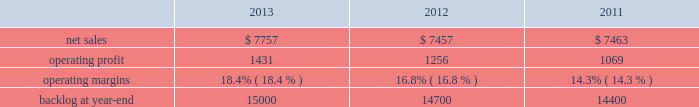Warfighter information network-tactical ( win-t ) ; command , control , battle management and communications ( c2bmc ) ; and twic ) .
Partially offsetting the decreases were higher net sales of approximately $ 140 million from qtc , which was acquired early in the fourth quarter of 2011 ; and about $ 65 million from increased activity on numerous other programs , primarily federal cyber security programs and ptds operational support .
Is&gs 2019 operating profit for 2012 decreased $ 66 million , or 8% ( 8 % ) , compared to 2011 .
The decrease was attributable to lower operating profit of approximately $ 50 million due to the favorable impact of the odin contract completion in 2011 ; about $ 25 million due to an increase in reserves for performance issues related to an international airborne surveillance system in 2012 ; and approximately $ 20 million due to lower volume on certain programs ( primarily c2bmc and win-t ) .
Partially offsetting the decreases was an increase in operating profit due to higher risk retirements of approximately $ 15 million from the twic program ; and about $ 10 million due to increased activity on numerous other programs , primarily federal cyber security programs and ptds operational support .
Operating profit for the jtrs program was comparable as a decrease in volume was offset by a decrease in reserves .
Adjustments not related to volume , including net profit booking rate adjustments and other matters described above , were approximately $ 20 million higher for 2012 compared to 2011 .
Backlog backlog decreased in 2013 compared to 2012 primarily due to lower orders on several programs ( such as eram and ngi ) , higher sales on certain programs ( the national science foundation antarctic support and the disa gsm-o ) , and declining activities on several smaller programs primarily due to the continued downturn in federal information technology budgets .
Backlog decreased in 2012 compared to 2011 primarily due to the substantial completion of various programs in 2011 ( primarily odin , u.k .
Census , and jtrs ) .
Trends we expect is&gs 2019 net sales to decline in 2014 in the high single digit percentage range as compared to 2013 primarily due to the continued downturn in federal information technology budgets .
Operating profit is also expected to decline in 2014 in the high single digit percentage range consistent with the expected decline in net sales , resulting in margins that are comparable with 2013 results .
Missiles and fire control our mfc business segment provides air and missile defense systems ; tactical missiles and air-to-ground precision strike weapon systems ; logistics and other technical services ; fire control systems ; mission operations support , readiness , engineering support , and integration services ; and manned and unmanned ground vehicles .
Mfc 2019s major programs include pac-3 , thaad , multiple launch rocket system , hellfire , joint air-to-surface standoff missile ( jassm ) , javelin , apache fire control system ( apache ) , sniper ae , low altitude navigation and targeting infrared for night ( lantirn ae ) , and sof clss .
Mfc 2019s operating results included the following ( in millions ) : .
2013 compared to 2012 mfc 2019s net sales for 2013 increased $ 300 million , or 4% ( 4 % ) , compared to 2012 .
The increase was primarily attributable to higher net sales of approximately $ 450 million for air and missile defense programs ( thaad and pac-3 ) due to increased production volume and deliveries ; about $ 70 million for fire control programs due to net increased deliveries and volume ; and approximately $ 55 million for tactical missile programs due to net increased deliveries .
The increases were partially offset by lower net sales of about $ 275 million for various technical services programs due to lower volume driven by the continuing impact of defense budget reductions and related competitive pressures .
The increase for fire control programs was primarily attributable to increased deliveries on the sniper ae and lantirn ae programs , increased volume on the sof clss program , partially offset by lower volume on longbow fire control radar and other programs .
The increase for tactical missile programs was primarily attributable to increased deliveries on jassm and other programs , partially offset by fewer deliveries on the guided multiple launch rocket system and javelin programs. .
What was the average backlog at year-end of mfc from 2011 to 2013? 
Computations: (((15000 + 14700) + 14400) / 3)
Answer: 14700.0. 